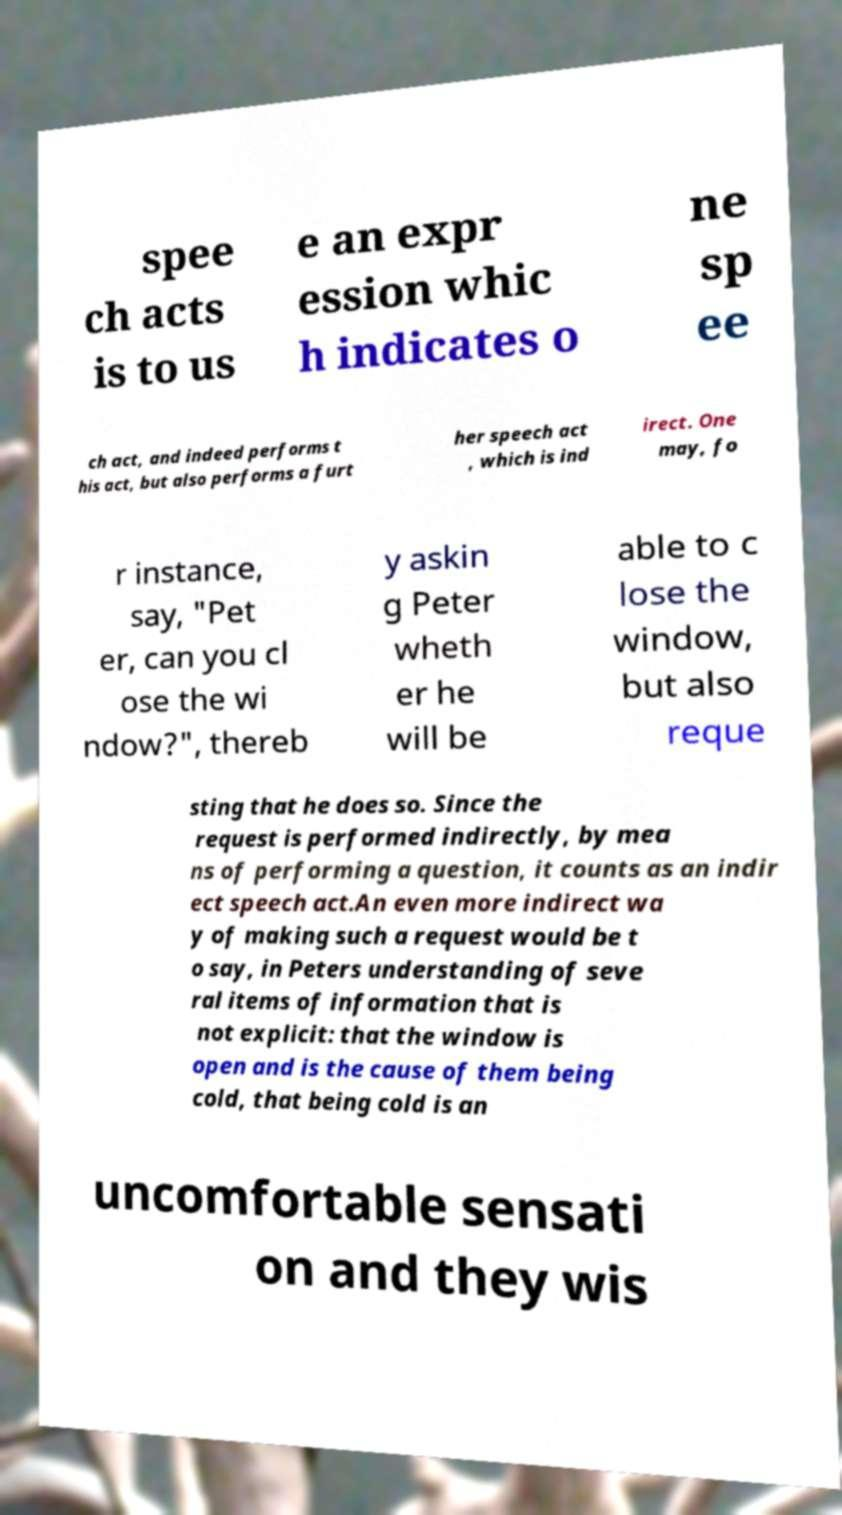There's text embedded in this image that I need extracted. Can you transcribe it verbatim? spee ch acts is to us e an expr ession whic h indicates o ne sp ee ch act, and indeed performs t his act, but also performs a furt her speech act , which is ind irect. One may, fo r instance, say, "Pet er, can you cl ose the wi ndow?", thereb y askin g Peter wheth er he will be able to c lose the window, but also reque sting that he does so. Since the request is performed indirectly, by mea ns of performing a question, it counts as an indir ect speech act.An even more indirect wa y of making such a request would be t o say, in Peters understanding of seve ral items of information that is not explicit: that the window is open and is the cause of them being cold, that being cold is an uncomfortable sensati on and they wis 